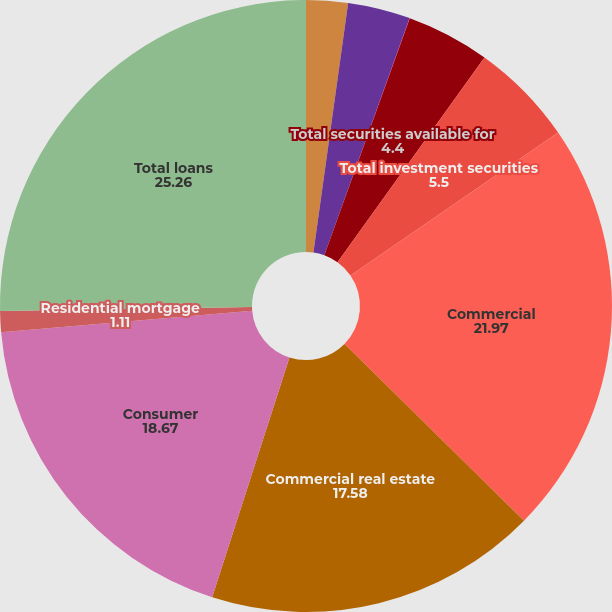Convert chart to OTSL. <chart><loc_0><loc_0><loc_500><loc_500><pie_chart><fcel>Non-agency<fcel>US Treasury and government<fcel>Other debt<fcel>Total securities available for<fcel>Total investment securities<fcel>Commercial<fcel>Commercial real estate<fcel>Consumer<fcel>Residential mortgage<fcel>Total loans<nl><fcel>2.2%<fcel>3.3%<fcel>0.01%<fcel>4.4%<fcel>5.5%<fcel>21.97%<fcel>17.58%<fcel>18.67%<fcel>1.11%<fcel>25.26%<nl></chart> 